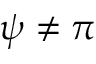<formula> <loc_0><loc_0><loc_500><loc_500>\psi \neq \pi</formula> 